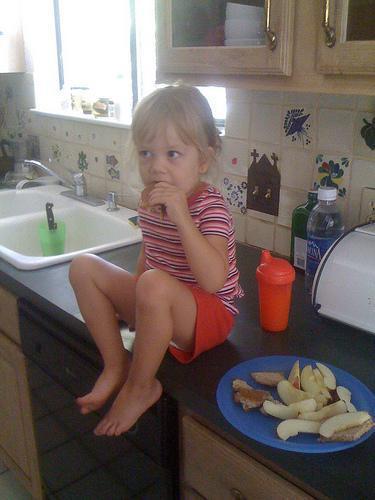How many kids on the counter?
Give a very brief answer. 1. 